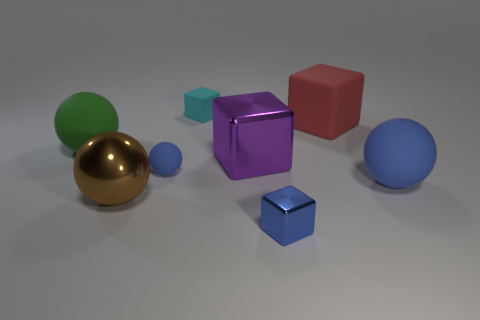Add 1 purple rubber things. How many objects exist? 9 Add 8 large brown spheres. How many large brown spheres are left? 9 Add 8 big brown metallic cylinders. How many big brown metallic cylinders exist? 8 Subtract 0 cyan balls. How many objects are left? 8 Subtract all small yellow shiny cylinders. Subtract all blue metallic things. How many objects are left? 7 